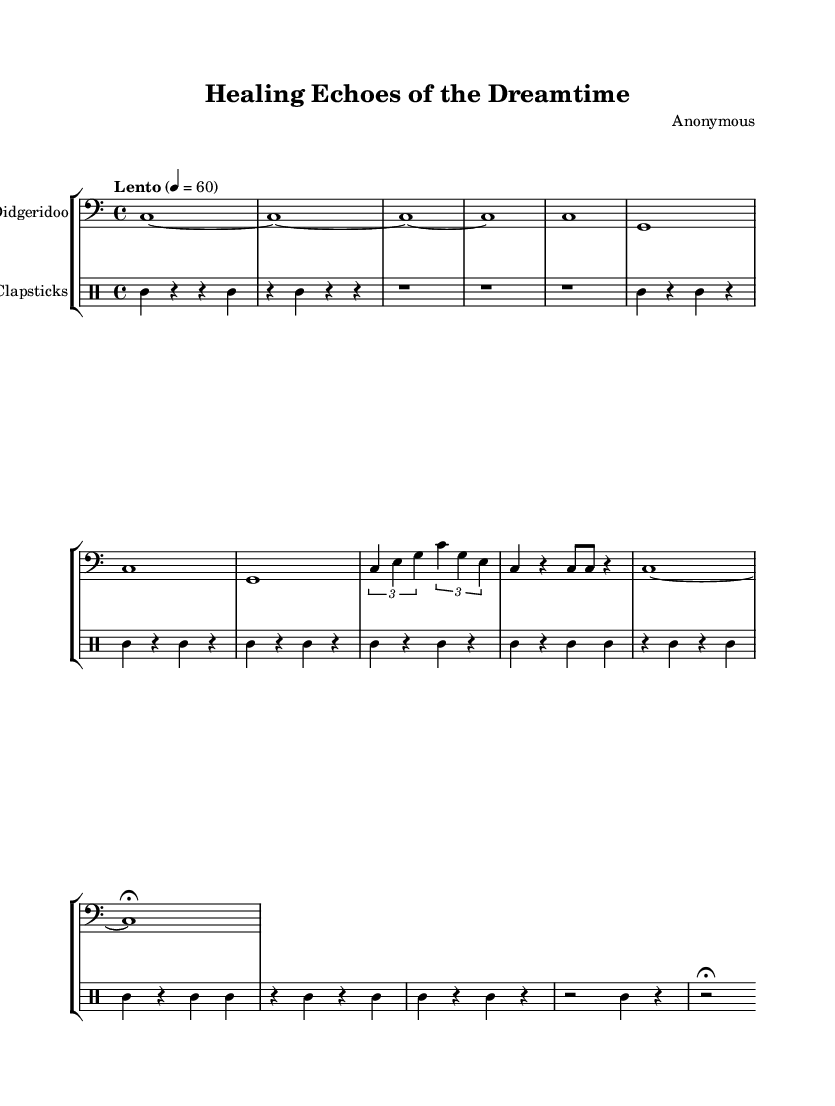What is the time signature of this music? The time signature is located at the beginning of the staff and is indicated as 4/4, meaning there are four beats per measure and the quarter note gets one beat.
Answer: 4/4 What is the tempo marking of this piece? The tempo marking is stated at the beginning, indicating that the piece should be played "Lento" at a speed of 60 beats per minute, which implies a slow pace.
Answer: Lento, 60 How many measures are in the main theme section? By reviewing the score, the main theme consists of four measures as indicated at the beginning of that section in the music.
Answer: 4 measures Which instrument plays the main melodic line? The notated staff labeled "Didgeridoo" shows the melodic content, confirming that this instrument carries the main melodic line throughout the piece.
Answer: Didgeridoo What are the two main rhythmic elements used in this composition? By examining the score, the two main rhythmic elements are the Didgeridoo for melody and the Clapsticks for percussion, creating a complementary texture characteristic of Indigenous Australian music.
Answer: Didgeridoo and Clapsticks In which section does the tempo slow down and what is that section called? The score shows that the tempo slows down in the last part labeled "Coda," where it features extended notes, indicating a final serene conclusion.
Answer: Coda What are the notes played in the variation section? The variation section consists of a combination of notes specified as c, e, and g, displayed in the tuplet form, which creates a rhythmic variation from the main theme.
Answer: c, e, g 